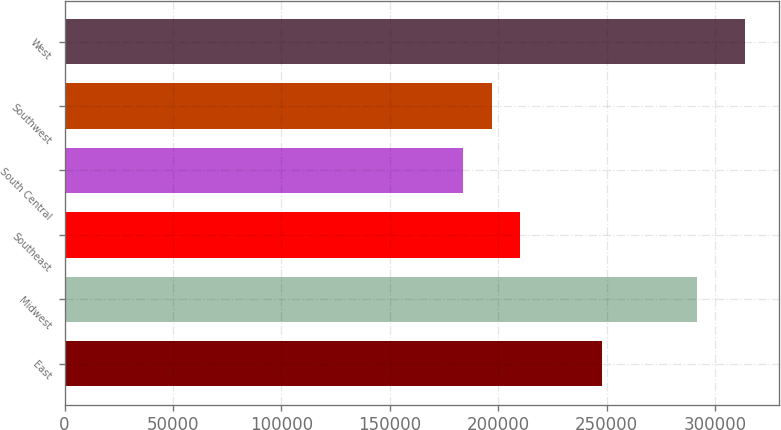<chart> <loc_0><loc_0><loc_500><loc_500><bar_chart><fcel>East<fcel>Midwest<fcel>Southeast<fcel>South Central<fcel>Southwest<fcel>West<nl><fcel>248000<fcel>291500<fcel>209920<fcel>183900<fcel>196910<fcel>314000<nl></chart> 